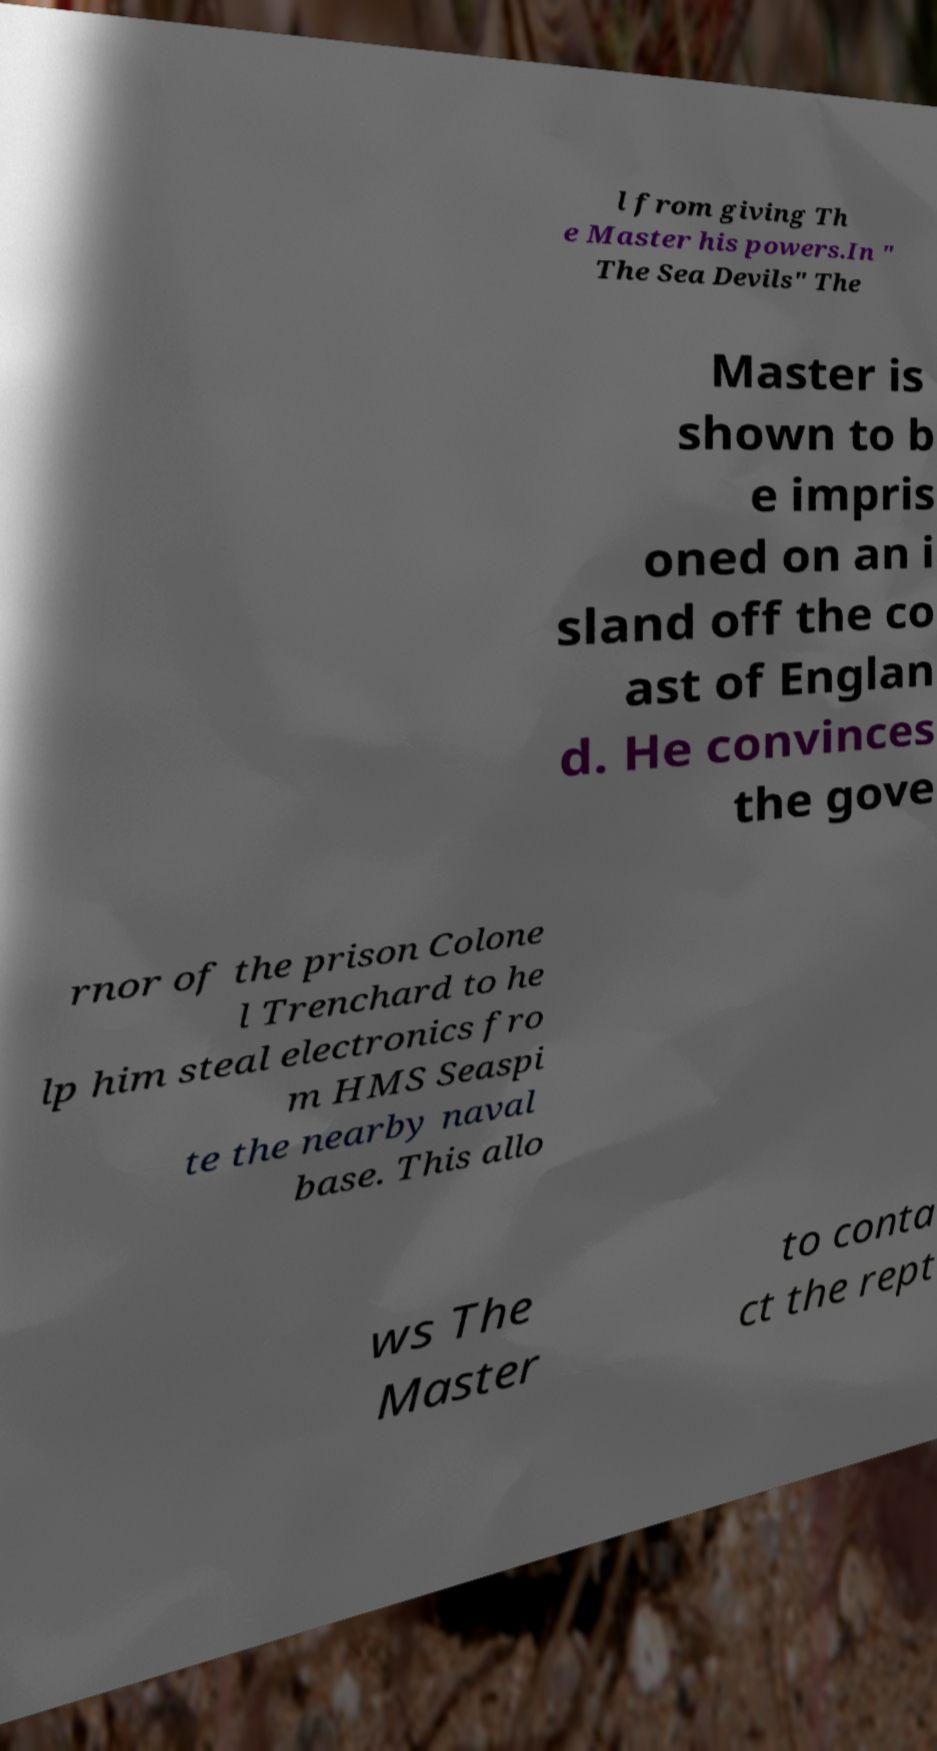Please identify and transcribe the text found in this image. l from giving Th e Master his powers.In " The Sea Devils" The Master is shown to b e impris oned on an i sland off the co ast of Englan d. He convinces the gove rnor of the prison Colone l Trenchard to he lp him steal electronics fro m HMS Seaspi te the nearby naval base. This allo ws The Master to conta ct the rept 